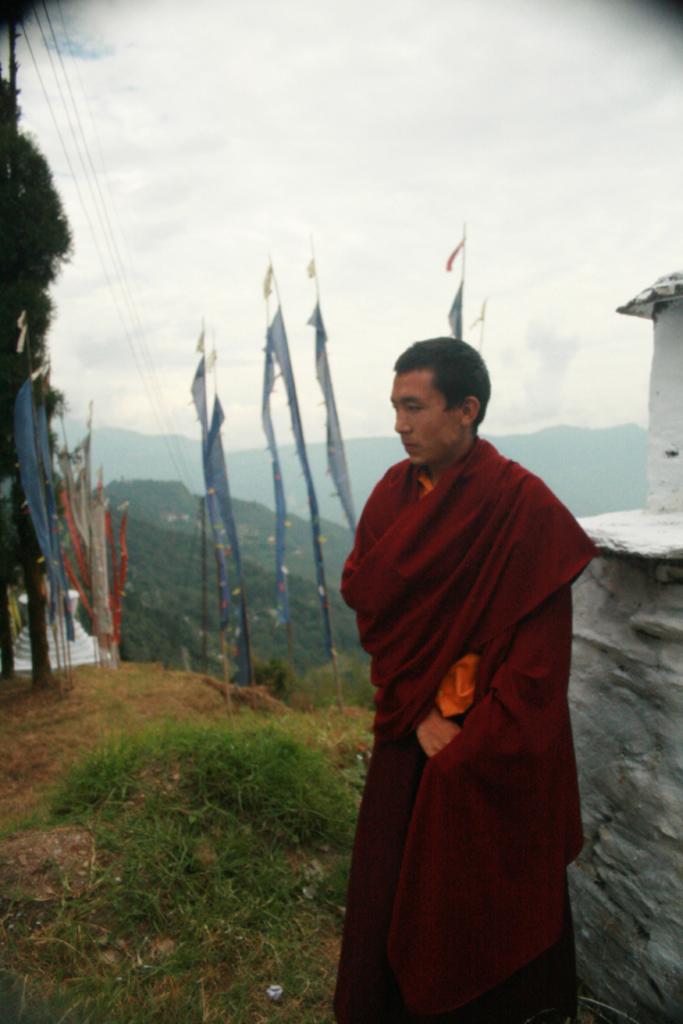Could you give a brief overview of what you see in this image? In this image we can see a person standing on the ground near a wall and there are few flags, trees, mountains, wires and the sky with clouds in the background. 